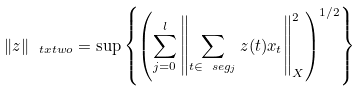<formula> <loc_0><loc_0><loc_500><loc_500>\| z \| _ { \ t x t w o } = \sup \left \{ \left ( \sum _ { j = 0 } ^ { l } \left \| \sum _ { t \in \ s e g _ { j } } z ( t ) x _ { t } \right \| ^ { 2 } _ { X } \right ) ^ { 1 / 2 } \right \}</formula> 